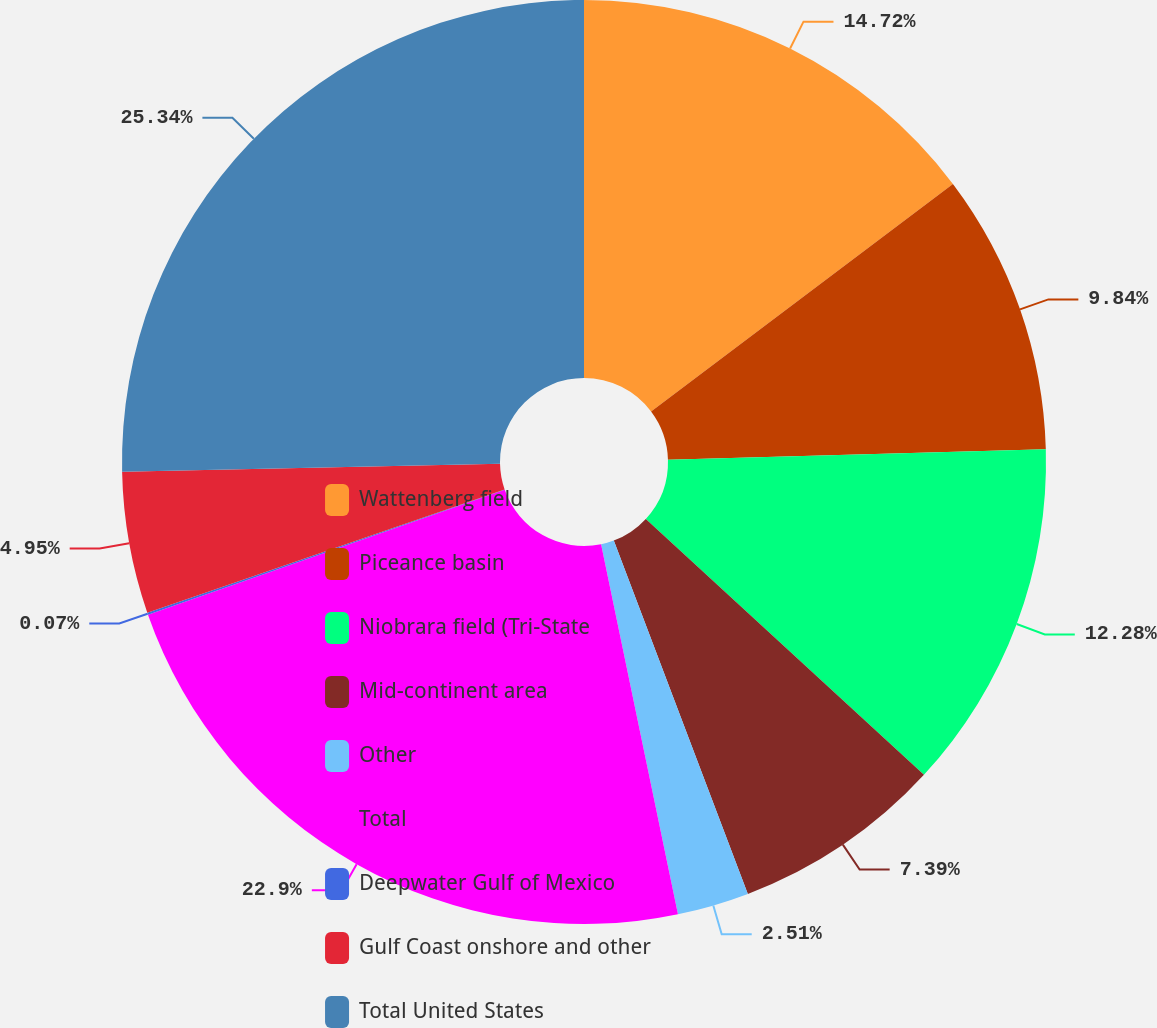<chart> <loc_0><loc_0><loc_500><loc_500><pie_chart><fcel>Wattenberg field<fcel>Piceance basin<fcel>Niobrara field (Tri-State<fcel>Mid-continent area<fcel>Other<fcel>Total<fcel>Deepwater Gulf of Mexico<fcel>Gulf Coast onshore and other<fcel>Total United States<nl><fcel>14.72%<fcel>9.84%<fcel>12.28%<fcel>7.39%<fcel>2.51%<fcel>22.9%<fcel>0.07%<fcel>4.95%<fcel>25.34%<nl></chart> 